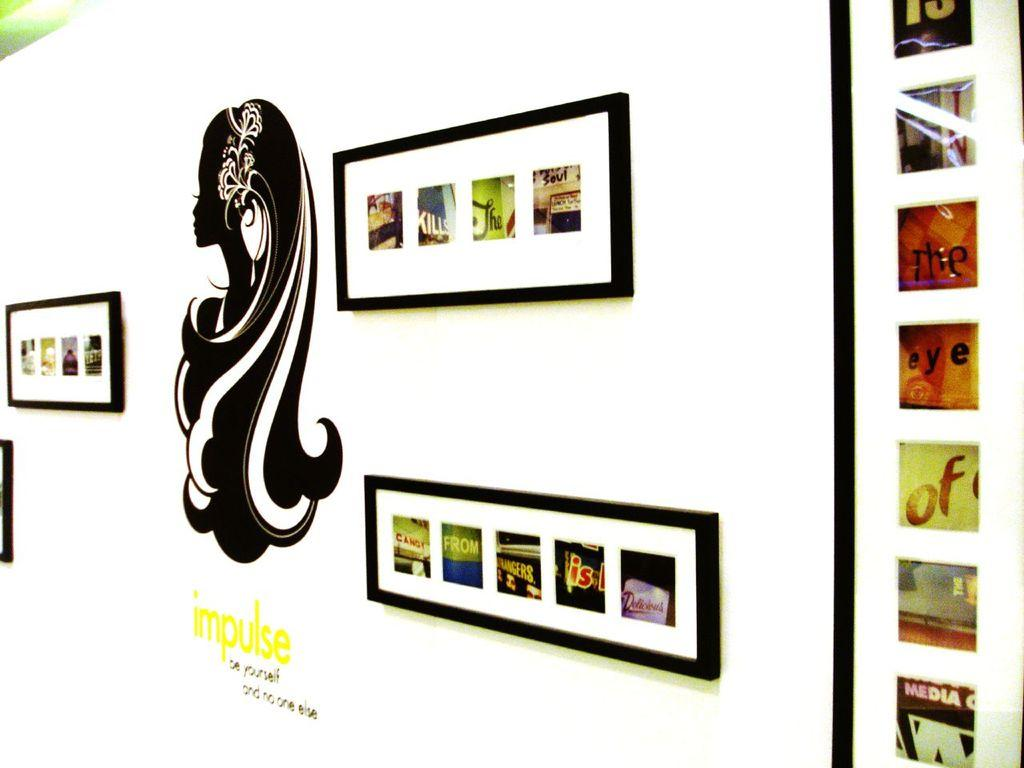<image>
Write a terse but informative summary of the picture. A woman silhouette is above the words IMPULSE  be yourself and no one else 